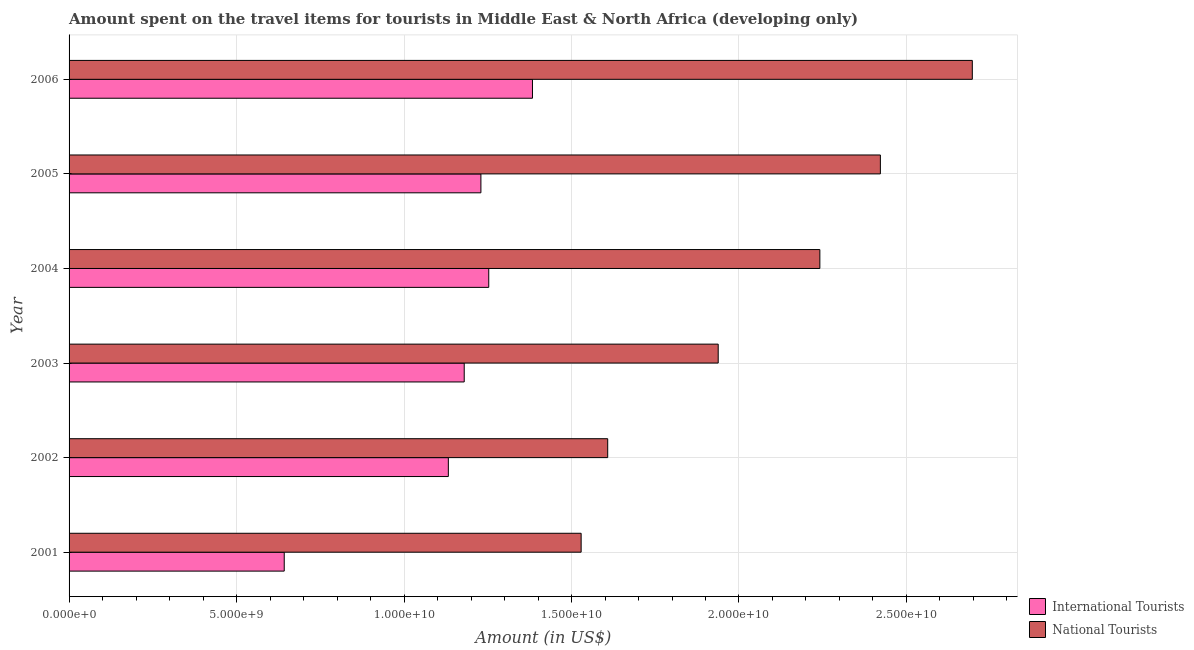Are the number of bars on each tick of the Y-axis equal?
Provide a succinct answer. Yes. How many bars are there on the 4th tick from the top?
Keep it short and to the point. 2. What is the amount spent on travel items of international tourists in 2006?
Provide a succinct answer. 1.38e+1. Across all years, what is the maximum amount spent on travel items of international tourists?
Ensure brevity in your answer.  1.38e+1. Across all years, what is the minimum amount spent on travel items of international tourists?
Give a very brief answer. 6.42e+09. In which year was the amount spent on travel items of international tourists maximum?
Make the answer very short. 2006. In which year was the amount spent on travel items of national tourists minimum?
Ensure brevity in your answer.  2001. What is the total amount spent on travel items of national tourists in the graph?
Provide a succinct answer. 1.24e+11. What is the difference between the amount spent on travel items of national tourists in 2002 and that in 2005?
Your answer should be compact. -8.14e+09. What is the difference between the amount spent on travel items of international tourists in 2005 and the amount spent on travel items of national tourists in 2003?
Offer a terse response. -7.08e+09. What is the average amount spent on travel items of national tourists per year?
Offer a terse response. 2.07e+1. In the year 2002, what is the difference between the amount spent on travel items of national tourists and amount spent on travel items of international tourists?
Your answer should be very brief. 4.76e+09. In how many years, is the amount spent on travel items of national tourists greater than 4000000000 US$?
Provide a short and direct response. 6. What is the ratio of the amount spent on travel items of national tourists in 2001 to that in 2003?
Ensure brevity in your answer.  0.79. What is the difference between the highest and the second highest amount spent on travel items of national tourists?
Provide a succinct answer. 2.74e+09. What is the difference between the highest and the lowest amount spent on travel items of national tourists?
Offer a very short reply. 1.17e+1. What does the 1st bar from the top in 2002 represents?
Ensure brevity in your answer.  National Tourists. What does the 1st bar from the bottom in 2002 represents?
Your response must be concise. International Tourists. How many bars are there?
Provide a succinct answer. 12. Are all the bars in the graph horizontal?
Your answer should be compact. Yes. What is the difference between two consecutive major ticks on the X-axis?
Your response must be concise. 5.00e+09. Does the graph contain any zero values?
Ensure brevity in your answer.  No. How are the legend labels stacked?
Keep it short and to the point. Vertical. What is the title of the graph?
Ensure brevity in your answer.  Amount spent on the travel items for tourists in Middle East & North Africa (developing only). Does "Research and Development" appear as one of the legend labels in the graph?
Your answer should be compact. No. What is the label or title of the X-axis?
Keep it short and to the point. Amount (in US$). What is the label or title of the Y-axis?
Keep it short and to the point. Year. What is the Amount (in US$) of International Tourists in 2001?
Your answer should be compact. 6.42e+09. What is the Amount (in US$) in National Tourists in 2001?
Your response must be concise. 1.53e+1. What is the Amount (in US$) in International Tourists in 2002?
Offer a very short reply. 1.13e+1. What is the Amount (in US$) in National Tourists in 2002?
Provide a succinct answer. 1.61e+1. What is the Amount (in US$) of International Tourists in 2003?
Your answer should be compact. 1.18e+1. What is the Amount (in US$) in National Tourists in 2003?
Keep it short and to the point. 1.94e+1. What is the Amount (in US$) in International Tourists in 2004?
Make the answer very short. 1.25e+1. What is the Amount (in US$) of National Tourists in 2004?
Make the answer very short. 2.24e+1. What is the Amount (in US$) of International Tourists in 2005?
Your response must be concise. 1.23e+1. What is the Amount (in US$) of National Tourists in 2005?
Give a very brief answer. 2.42e+1. What is the Amount (in US$) of International Tourists in 2006?
Ensure brevity in your answer.  1.38e+1. What is the Amount (in US$) of National Tourists in 2006?
Your answer should be compact. 2.70e+1. Across all years, what is the maximum Amount (in US$) of International Tourists?
Provide a succinct answer. 1.38e+1. Across all years, what is the maximum Amount (in US$) in National Tourists?
Your answer should be compact. 2.70e+1. Across all years, what is the minimum Amount (in US$) of International Tourists?
Your answer should be compact. 6.42e+09. Across all years, what is the minimum Amount (in US$) in National Tourists?
Keep it short and to the point. 1.53e+1. What is the total Amount (in US$) in International Tourists in the graph?
Your response must be concise. 6.82e+1. What is the total Amount (in US$) in National Tourists in the graph?
Provide a short and direct response. 1.24e+11. What is the difference between the Amount (in US$) in International Tourists in 2001 and that in 2002?
Make the answer very short. -4.90e+09. What is the difference between the Amount (in US$) of National Tourists in 2001 and that in 2002?
Offer a very short reply. -7.93e+08. What is the difference between the Amount (in US$) of International Tourists in 2001 and that in 2003?
Your answer should be very brief. -5.37e+09. What is the difference between the Amount (in US$) of National Tourists in 2001 and that in 2003?
Give a very brief answer. -4.09e+09. What is the difference between the Amount (in US$) of International Tourists in 2001 and that in 2004?
Ensure brevity in your answer.  -6.11e+09. What is the difference between the Amount (in US$) in National Tourists in 2001 and that in 2004?
Keep it short and to the point. -7.13e+09. What is the difference between the Amount (in US$) in International Tourists in 2001 and that in 2005?
Give a very brief answer. -5.87e+09. What is the difference between the Amount (in US$) in National Tourists in 2001 and that in 2005?
Provide a succinct answer. -8.93e+09. What is the difference between the Amount (in US$) in International Tourists in 2001 and that in 2006?
Offer a terse response. -7.41e+09. What is the difference between the Amount (in US$) of National Tourists in 2001 and that in 2006?
Give a very brief answer. -1.17e+1. What is the difference between the Amount (in US$) in International Tourists in 2002 and that in 2003?
Provide a short and direct response. -4.74e+08. What is the difference between the Amount (in US$) in National Tourists in 2002 and that in 2003?
Offer a terse response. -3.30e+09. What is the difference between the Amount (in US$) in International Tourists in 2002 and that in 2004?
Offer a terse response. -1.21e+09. What is the difference between the Amount (in US$) in National Tourists in 2002 and that in 2004?
Your answer should be compact. -6.33e+09. What is the difference between the Amount (in US$) in International Tourists in 2002 and that in 2005?
Your response must be concise. -9.72e+08. What is the difference between the Amount (in US$) of National Tourists in 2002 and that in 2005?
Ensure brevity in your answer.  -8.14e+09. What is the difference between the Amount (in US$) of International Tourists in 2002 and that in 2006?
Provide a short and direct response. -2.51e+09. What is the difference between the Amount (in US$) of National Tourists in 2002 and that in 2006?
Your answer should be very brief. -1.09e+1. What is the difference between the Amount (in US$) of International Tourists in 2003 and that in 2004?
Give a very brief answer. -7.32e+08. What is the difference between the Amount (in US$) of National Tourists in 2003 and that in 2004?
Your answer should be compact. -3.03e+09. What is the difference between the Amount (in US$) of International Tourists in 2003 and that in 2005?
Keep it short and to the point. -4.98e+08. What is the difference between the Amount (in US$) in National Tourists in 2003 and that in 2005?
Keep it short and to the point. -4.84e+09. What is the difference between the Amount (in US$) in International Tourists in 2003 and that in 2006?
Make the answer very short. -2.04e+09. What is the difference between the Amount (in US$) of National Tourists in 2003 and that in 2006?
Give a very brief answer. -7.59e+09. What is the difference between the Amount (in US$) of International Tourists in 2004 and that in 2005?
Provide a succinct answer. 2.34e+08. What is the difference between the Amount (in US$) in National Tourists in 2004 and that in 2005?
Your response must be concise. -1.81e+09. What is the difference between the Amount (in US$) in International Tourists in 2004 and that in 2006?
Provide a short and direct response. -1.31e+09. What is the difference between the Amount (in US$) of National Tourists in 2004 and that in 2006?
Offer a very short reply. -4.55e+09. What is the difference between the Amount (in US$) of International Tourists in 2005 and that in 2006?
Provide a succinct answer. -1.54e+09. What is the difference between the Amount (in US$) in National Tourists in 2005 and that in 2006?
Offer a terse response. -2.74e+09. What is the difference between the Amount (in US$) in International Tourists in 2001 and the Amount (in US$) in National Tourists in 2002?
Keep it short and to the point. -9.66e+09. What is the difference between the Amount (in US$) of International Tourists in 2001 and the Amount (in US$) of National Tourists in 2003?
Provide a short and direct response. -1.30e+1. What is the difference between the Amount (in US$) in International Tourists in 2001 and the Amount (in US$) in National Tourists in 2004?
Give a very brief answer. -1.60e+1. What is the difference between the Amount (in US$) of International Tourists in 2001 and the Amount (in US$) of National Tourists in 2005?
Keep it short and to the point. -1.78e+1. What is the difference between the Amount (in US$) in International Tourists in 2001 and the Amount (in US$) in National Tourists in 2006?
Keep it short and to the point. -2.05e+1. What is the difference between the Amount (in US$) of International Tourists in 2002 and the Amount (in US$) of National Tourists in 2003?
Offer a very short reply. -8.06e+09. What is the difference between the Amount (in US$) in International Tourists in 2002 and the Amount (in US$) in National Tourists in 2004?
Ensure brevity in your answer.  -1.11e+1. What is the difference between the Amount (in US$) in International Tourists in 2002 and the Amount (in US$) in National Tourists in 2005?
Your response must be concise. -1.29e+1. What is the difference between the Amount (in US$) of International Tourists in 2002 and the Amount (in US$) of National Tourists in 2006?
Your response must be concise. -1.56e+1. What is the difference between the Amount (in US$) of International Tourists in 2003 and the Amount (in US$) of National Tourists in 2004?
Provide a succinct answer. -1.06e+1. What is the difference between the Amount (in US$) of International Tourists in 2003 and the Amount (in US$) of National Tourists in 2005?
Make the answer very short. -1.24e+1. What is the difference between the Amount (in US$) of International Tourists in 2003 and the Amount (in US$) of National Tourists in 2006?
Provide a short and direct response. -1.52e+1. What is the difference between the Amount (in US$) in International Tourists in 2004 and the Amount (in US$) in National Tourists in 2005?
Make the answer very short. -1.17e+1. What is the difference between the Amount (in US$) of International Tourists in 2004 and the Amount (in US$) of National Tourists in 2006?
Offer a terse response. -1.44e+1. What is the difference between the Amount (in US$) of International Tourists in 2005 and the Amount (in US$) of National Tourists in 2006?
Keep it short and to the point. -1.47e+1. What is the average Amount (in US$) of International Tourists per year?
Your answer should be very brief. 1.14e+1. What is the average Amount (in US$) of National Tourists per year?
Offer a terse response. 2.07e+1. In the year 2001, what is the difference between the Amount (in US$) in International Tourists and Amount (in US$) in National Tourists?
Ensure brevity in your answer.  -8.86e+09. In the year 2002, what is the difference between the Amount (in US$) of International Tourists and Amount (in US$) of National Tourists?
Offer a very short reply. -4.76e+09. In the year 2003, what is the difference between the Amount (in US$) of International Tourists and Amount (in US$) of National Tourists?
Your answer should be very brief. -7.58e+09. In the year 2004, what is the difference between the Amount (in US$) in International Tourists and Amount (in US$) in National Tourists?
Your answer should be very brief. -9.89e+09. In the year 2005, what is the difference between the Amount (in US$) of International Tourists and Amount (in US$) of National Tourists?
Provide a short and direct response. -1.19e+1. In the year 2006, what is the difference between the Amount (in US$) in International Tourists and Amount (in US$) in National Tourists?
Provide a succinct answer. -1.31e+1. What is the ratio of the Amount (in US$) in International Tourists in 2001 to that in 2002?
Provide a short and direct response. 0.57. What is the ratio of the Amount (in US$) of National Tourists in 2001 to that in 2002?
Make the answer very short. 0.95. What is the ratio of the Amount (in US$) of International Tourists in 2001 to that in 2003?
Provide a short and direct response. 0.54. What is the ratio of the Amount (in US$) in National Tourists in 2001 to that in 2003?
Make the answer very short. 0.79. What is the ratio of the Amount (in US$) in International Tourists in 2001 to that in 2004?
Ensure brevity in your answer.  0.51. What is the ratio of the Amount (in US$) in National Tourists in 2001 to that in 2004?
Keep it short and to the point. 0.68. What is the ratio of the Amount (in US$) in International Tourists in 2001 to that in 2005?
Your response must be concise. 0.52. What is the ratio of the Amount (in US$) of National Tourists in 2001 to that in 2005?
Offer a terse response. 0.63. What is the ratio of the Amount (in US$) in International Tourists in 2001 to that in 2006?
Offer a terse response. 0.46. What is the ratio of the Amount (in US$) of National Tourists in 2001 to that in 2006?
Your answer should be compact. 0.57. What is the ratio of the Amount (in US$) of International Tourists in 2002 to that in 2003?
Your response must be concise. 0.96. What is the ratio of the Amount (in US$) in National Tourists in 2002 to that in 2003?
Your answer should be very brief. 0.83. What is the ratio of the Amount (in US$) of International Tourists in 2002 to that in 2004?
Keep it short and to the point. 0.9. What is the ratio of the Amount (in US$) in National Tourists in 2002 to that in 2004?
Make the answer very short. 0.72. What is the ratio of the Amount (in US$) of International Tourists in 2002 to that in 2005?
Give a very brief answer. 0.92. What is the ratio of the Amount (in US$) of National Tourists in 2002 to that in 2005?
Offer a terse response. 0.66. What is the ratio of the Amount (in US$) in International Tourists in 2002 to that in 2006?
Keep it short and to the point. 0.82. What is the ratio of the Amount (in US$) of National Tourists in 2002 to that in 2006?
Offer a very short reply. 0.6. What is the ratio of the Amount (in US$) in International Tourists in 2003 to that in 2004?
Provide a succinct answer. 0.94. What is the ratio of the Amount (in US$) of National Tourists in 2003 to that in 2004?
Give a very brief answer. 0.86. What is the ratio of the Amount (in US$) of International Tourists in 2003 to that in 2005?
Provide a succinct answer. 0.96. What is the ratio of the Amount (in US$) in National Tourists in 2003 to that in 2005?
Offer a very short reply. 0.8. What is the ratio of the Amount (in US$) in International Tourists in 2003 to that in 2006?
Offer a very short reply. 0.85. What is the ratio of the Amount (in US$) of National Tourists in 2003 to that in 2006?
Keep it short and to the point. 0.72. What is the ratio of the Amount (in US$) of International Tourists in 2004 to that in 2005?
Provide a succinct answer. 1.02. What is the ratio of the Amount (in US$) of National Tourists in 2004 to that in 2005?
Provide a short and direct response. 0.93. What is the ratio of the Amount (in US$) of International Tourists in 2004 to that in 2006?
Your response must be concise. 0.91. What is the ratio of the Amount (in US$) of National Tourists in 2004 to that in 2006?
Your answer should be very brief. 0.83. What is the ratio of the Amount (in US$) in International Tourists in 2005 to that in 2006?
Your response must be concise. 0.89. What is the ratio of the Amount (in US$) in National Tourists in 2005 to that in 2006?
Give a very brief answer. 0.9. What is the difference between the highest and the second highest Amount (in US$) of International Tourists?
Your answer should be very brief. 1.31e+09. What is the difference between the highest and the second highest Amount (in US$) in National Tourists?
Keep it short and to the point. 2.74e+09. What is the difference between the highest and the lowest Amount (in US$) in International Tourists?
Keep it short and to the point. 7.41e+09. What is the difference between the highest and the lowest Amount (in US$) in National Tourists?
Your answer should be very brief. 1.17e+1. 